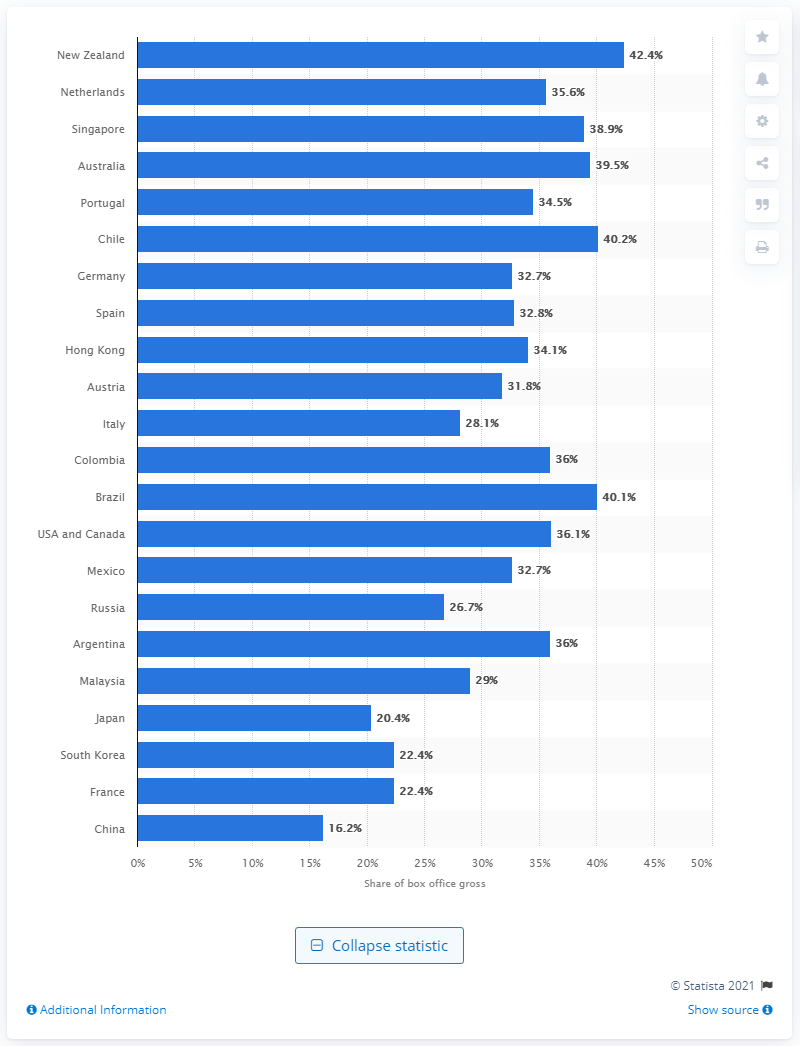Point out several critical features in this image. In 2019, UK films represented approximately 36% of the box office gross in North America. 